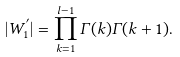Convert formula to latex. <formula><loc_0><loc_0><loc_500><loc_500>| W ^ { ^ { \prime } } _ { 1 } | = \prod _ { k = 1 } ^ { l - 1 } \Gamma ( k ) \Gamma ( k + 1 ) .</formula> 